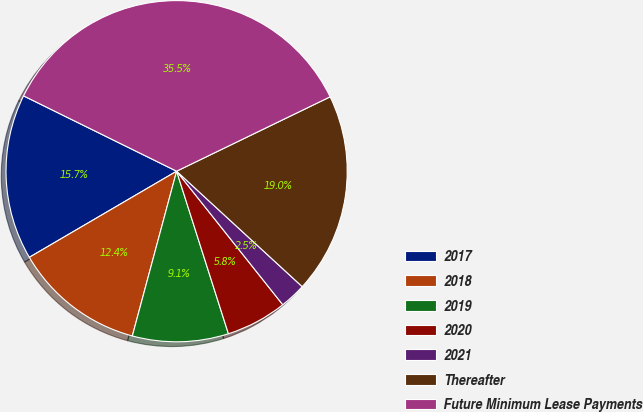Convert chart to OTSL. <chart><loc_0><loc_0><loc_500><loc_500><pie_chart><fcel>2017<fcel>2018<fcel>2019<fcel>2020<fcel>2021<fcel>Thereafter<fcel>Future Minimum Lease Payments<nl><fcel>15.7%<fcel>12.4%<fcel>9.09%<fcel>5.78%<fcel>2.48%<fcel>19.01%<fcel>35.54%<nl></chart> 